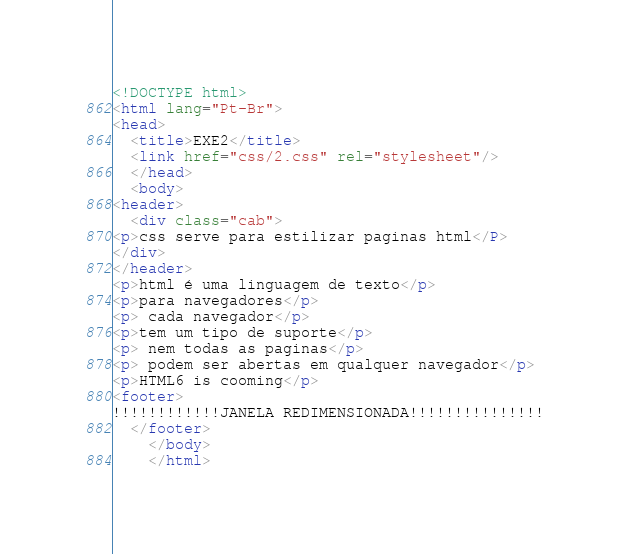Convert code to text. <code><loc_0><loc_0><loc_500><loc_500><_HTML_><!DOCTYPE html>
<html lang="Pt-Br">
<head>
  <title>EXE2</title>
  <link href="css/2.css" rel="stylesheet"/>
  </head>
  <body>
<header>
  <div class="cab">
<p>css serve para estilizar paginas html</P>
</div>
</header>
<p>html é uma linguagem de texto</p>
<p>para navegadores</p>
<p> cada navegador</p>
<p>tem um tipo de suporte</p>
<p> nem todas as paginas</p>
<p> podem ser abertas em qualquer navegador</p>
<p>HTML6 is cooming</p>
<footer>
!!!!!!!!!!!!JANELA REDIMENSIONADA!!!!!!!!!!!!!!!
  </footer>
    </body>
    </html>
</code> 